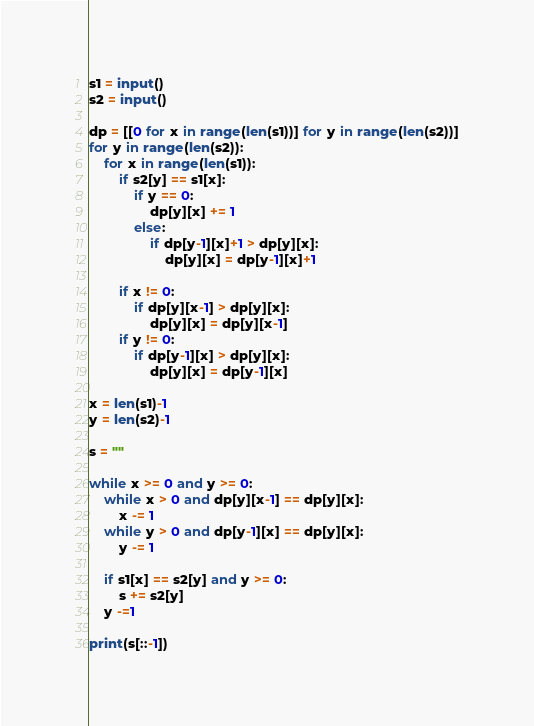Convert code to text. <code><loc_0><loc_0><loc_500><loc_500><_Python_>s1 = input()
s2 = input()

dp = [[0 for x in range(len(s1))] for y in range(len(s2))]
for y in range(len(s2)):
    for x in range(len(s1)):
        if s2[y] == s1[x]:
            if y == 0:
                dp[y][x] += 1
            else:
                if dp[y-1][x]+1 > dp[y][x]:
                    dp[y][x] = dp[y-1][x]+1

        if x != 0:
            if dp[y][x-1] > dp[y][x]:
                dp[y][x] = dp[y][x-1]
        if y != 0:
            if dp[y-1][x] > dp[y][x]:
                dp[y][x] = dp[y-1][x]

x = len(s1)-1
y = len(s2)-1

s = ""

while x >= 0 and y >= 0:
    while x > 0 and dp[y][x-1] == dp[y][x]:
        x -= 1
    while y > 0 and dp[y-1][x] == dp[y][x]:
        y -= 1

    if s1[x] == s2[y] and y >= 0:
        s += s2[y]
    y -=1

print(s[::-1])
</code> 